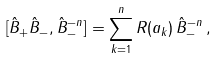Convert formula to latex. <formula><loc_0><loc_0><loc_500><loc_500>[ \hat { B } _ { + } \hat { B } _ { - } , \hat { B } _ { - } ^ { - n } ] = \sum _ { k = 1 } ^ { n } R ( a _ { k } ) \, \hat { B } _ { - } ^ { - n } \, ,</formula> 